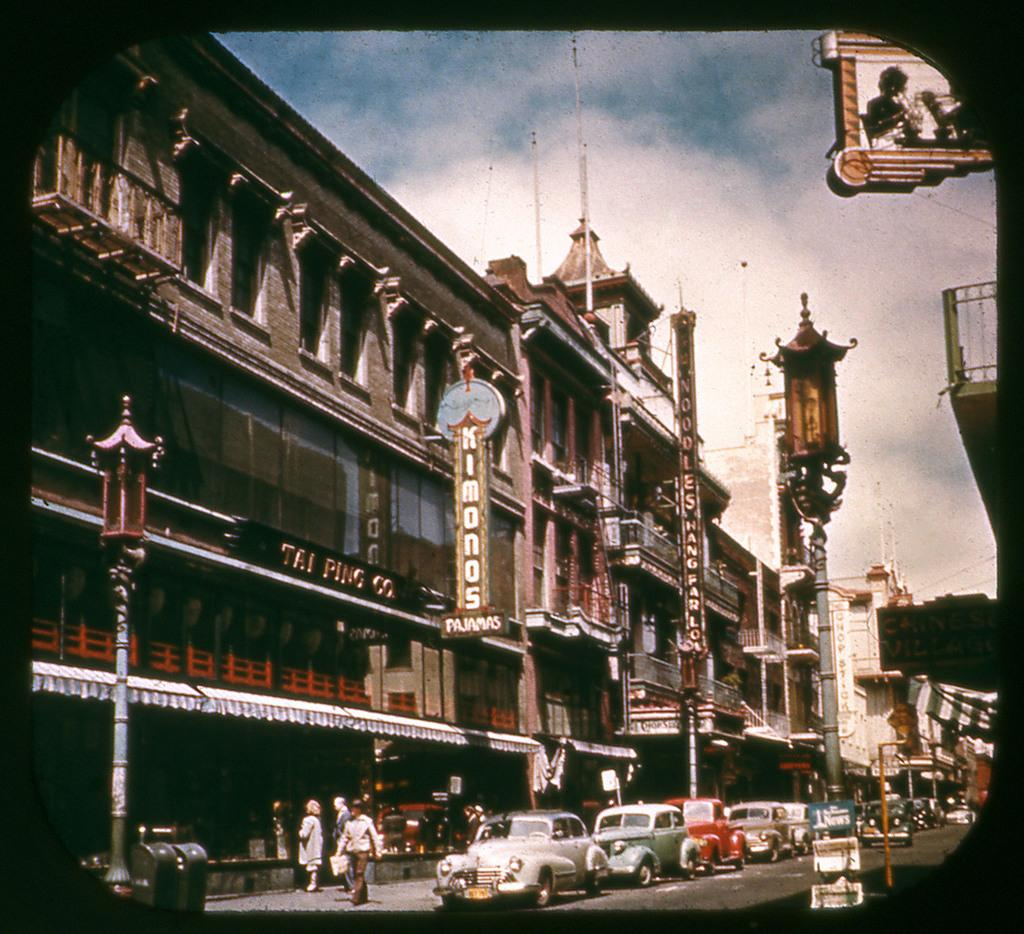<image>
Share a concise interpretation of the image provided. an old street scene of cars in front o the Tai Ping Co building 